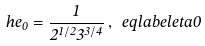<formula> <loc_0><loc_0><loc_500><loc_500>\ h e _ { 0 } = \frac { 1 } { 2 ^ { 1 / 2 } 3 ^ { 3 / 4 } } \, , \ e q l a b e l { e t a 0 }</formula> 